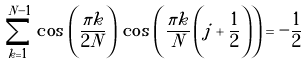Convert formula to latex. <formula><loc_0><loc_0><loc_500><loc_500>\sum ^ { N - 1 } _ { k = 1 } \, \cos \, \left ( \frac { \pi k } { 2 N } \right ) \, \cos \, \left ( \frac { \pi k } { N } \left ( j + \frac { 1 } { 2 } \right ) \right ) = - \frac { 1 } { 2 }</formula> 